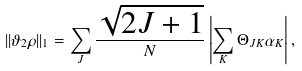<formula> <loc_0><loc_0><loc_500><loc_500>| | \vartheta _ { 2 } \rho | | _ { 1 } = \sum _ { J } \frac { \sqrt { 2 J + 1 } } { N } \left | \sum _ { K } \Theta _ { J K } \alpha _ { K } \right | ,</formula> 